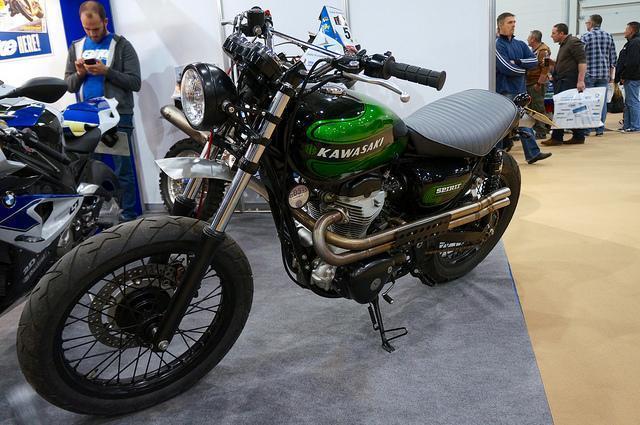How many motorcycles are in the picture?
Give a very brief answer. 2. How many people can you see?
Give a very brief answer. 5. 